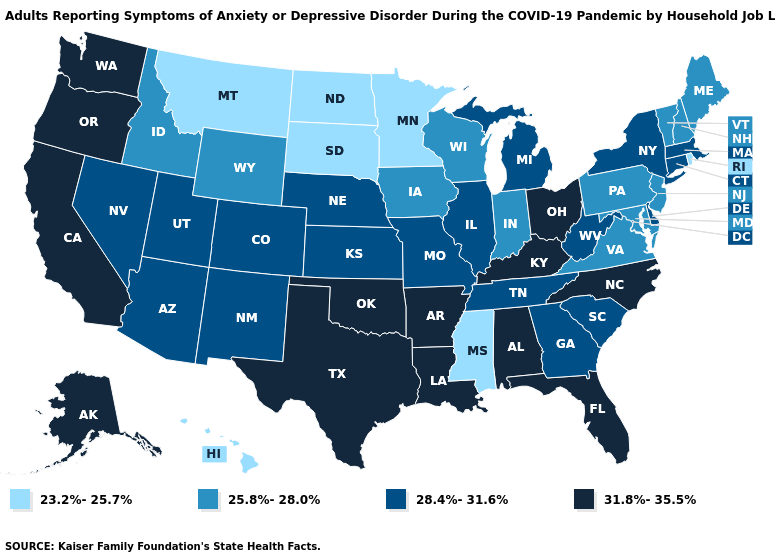Does Delaware have the lowest value in the USA?
Answer briefly. No. Which states hav the highest value in the MidWest?
Be succinct. Ohio. What is the lowest value in the South?
Quick response, please. 23.2%-25.7%. Among the states that border South Carolina , which have the lowest value?
Keep it brief. Georgia. Name the states that have a value in the range 25.8%-28.0%?
Concise answer only. Idaho, Indiana, Iowa, Maine, Maryland, New Hampshire, New Jersey, Pennsylvania, Vermont, Virginia, Wisconsin, Wyoming. Name the states that have a value in the range 23.2%-25.7%?
Write a very short answer. Hawaii, Minnesota, Mississippi, Montana, North Dakota, Rhode Island, South Dakota. What is the highest value in states that border Kansas?
Short answer required. 31.8%-35.5%. What is the value of New Jersey?
Give a very brief answer. 25.8%-28.0%. Among the states that border Vermont , which have the lowest value?
Keep it brief. New Hampshire. Does Ohio have the same value as Oklahoma?
Write a very short answer. Yes. What is the highest value in the USA?
Give a very brief answer. 31.8%-35.5%. Name the states that have a value in the range 25.8%-28.0%?
Quick response, please. Idaho, Indiana, Iowa, Maine, Maryland, New Hampshire, New Jersey, Pennsylvania, Vermont, Virginia, Wisconsin, Wyoming. Among the states that border New Mexico , which have the lowest value?
Be succinct. Arizona, Colorado, Utah. Does Maine have a lower value than New Hampshire?
Give a very brief answer. No. How many symbols are there in the legend?
Answer briefly. 4. 